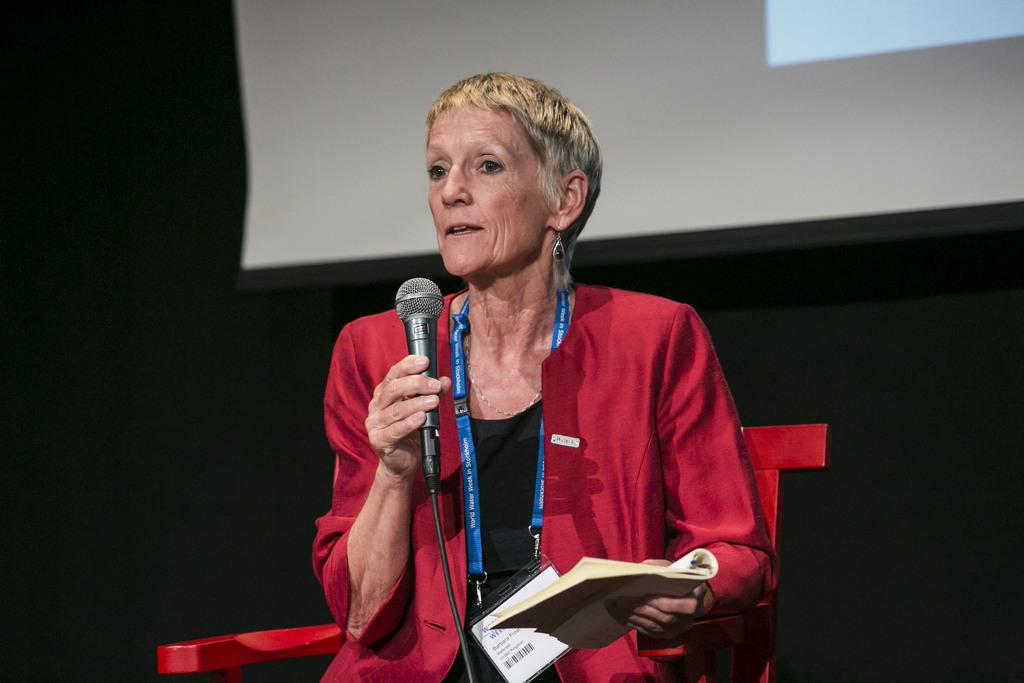Who is the main subject in the image? There is a woman in the image. What is the woman holding in her hand? The woman is holding a microphone in her hand. What is the woman doing with her mouth? The woman's mouth is open. What else is the woman holding in her other hand? The woman is holding a book in her other hand. What type of plantation can be seen in the background of the image? There is no plantation visible in the image; it only features a woman holding a microphone and a book. 